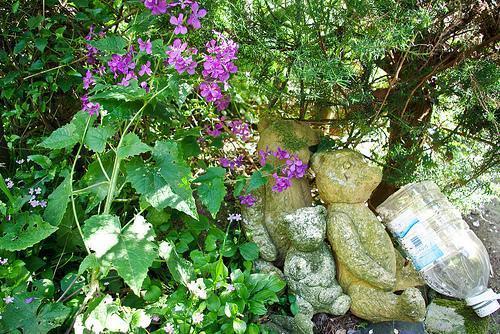How many plastic bottles?
Give a very brief answer. 1. How many bear statues?
Give a very brief answer. 3. How many bear statues are brown?
Give a very brief answer. 2. How many bears are there?
Give a very brief answer. 3. How many bottles are there?
Give a very brief answer. 1. How many bear statues are there?
Give a very brief answer. 3. 